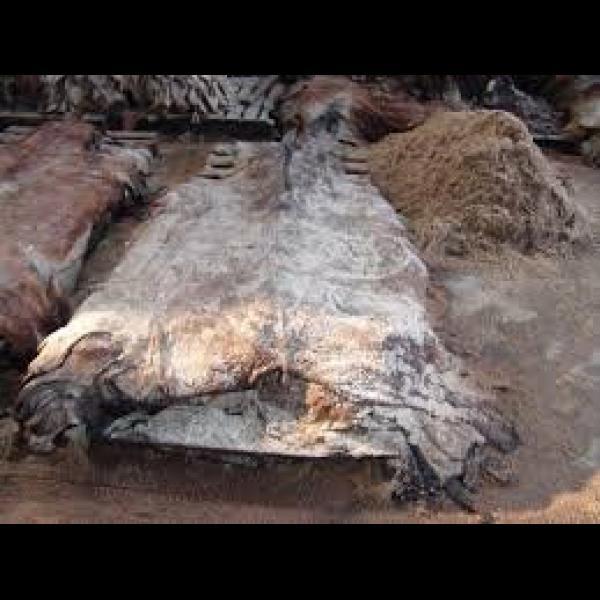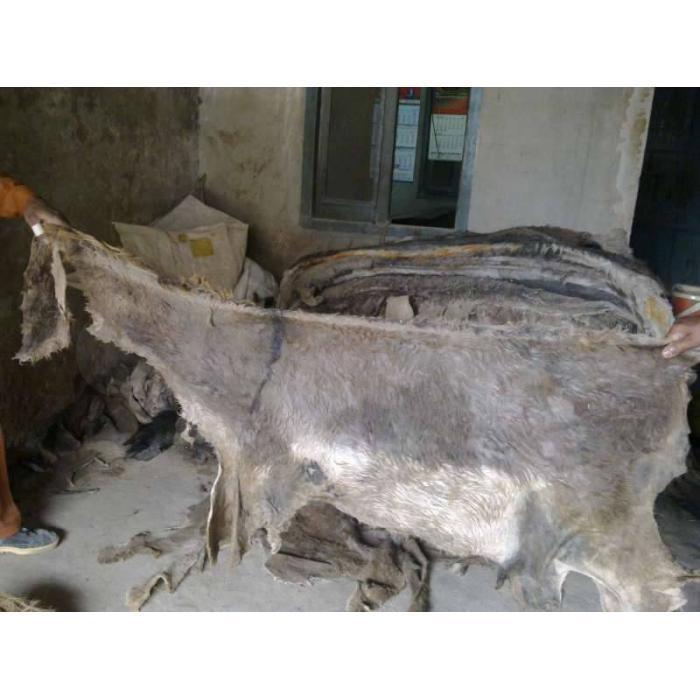The first image is the image on the left, the second image is the image on the right. Given the left and right images, does the statement "At least one image shows a non-living water buffalo, with its actual flesh removed." hold true? Answer yes or no. Yes. The first image is the image on the left, the second image is the image on the right. Examine the images to the left and right. Is the description "water buffalo stare straight at the camera" accurate? Answer yes or no. No. 